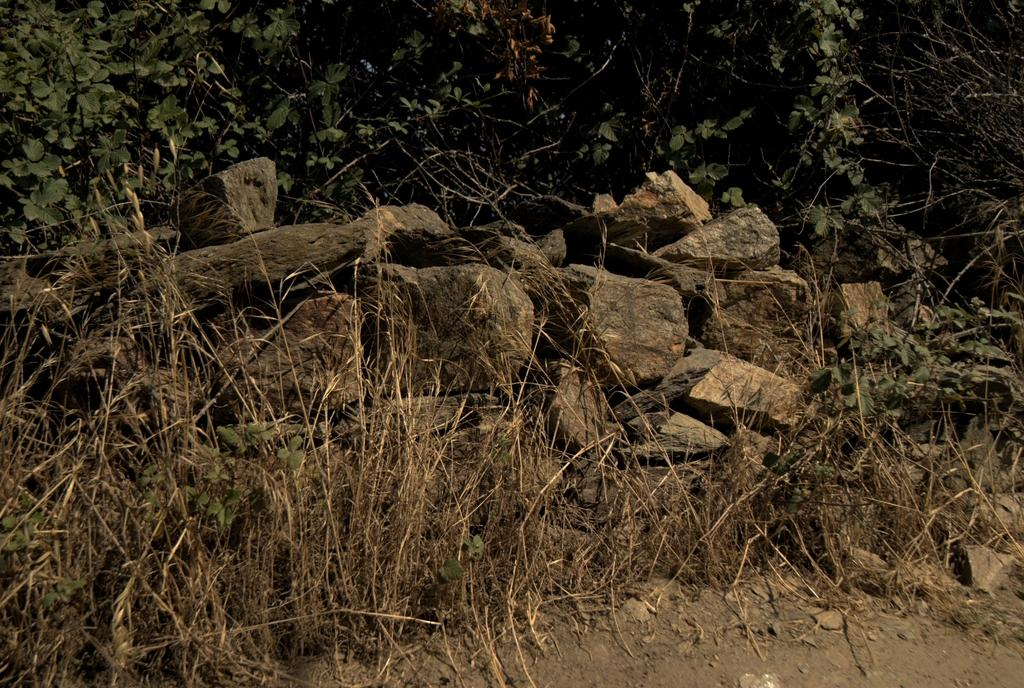What is the main subject in the center of the image? There are stones in the center of the image. What type of terrain is visible at the bottom of the image? Dry grass and mud are present at the bottom of the image. What can be seen in the background of the image? There are plants in the background of the image. What type of meal is being prepared in the image? There is no meal preparation visible in the image; it features stones, dry grass and mud, and plants. What type of celery can be seen growing in the image? There is no celery present in the image; it features stones, dry grass and mud, and plants. 